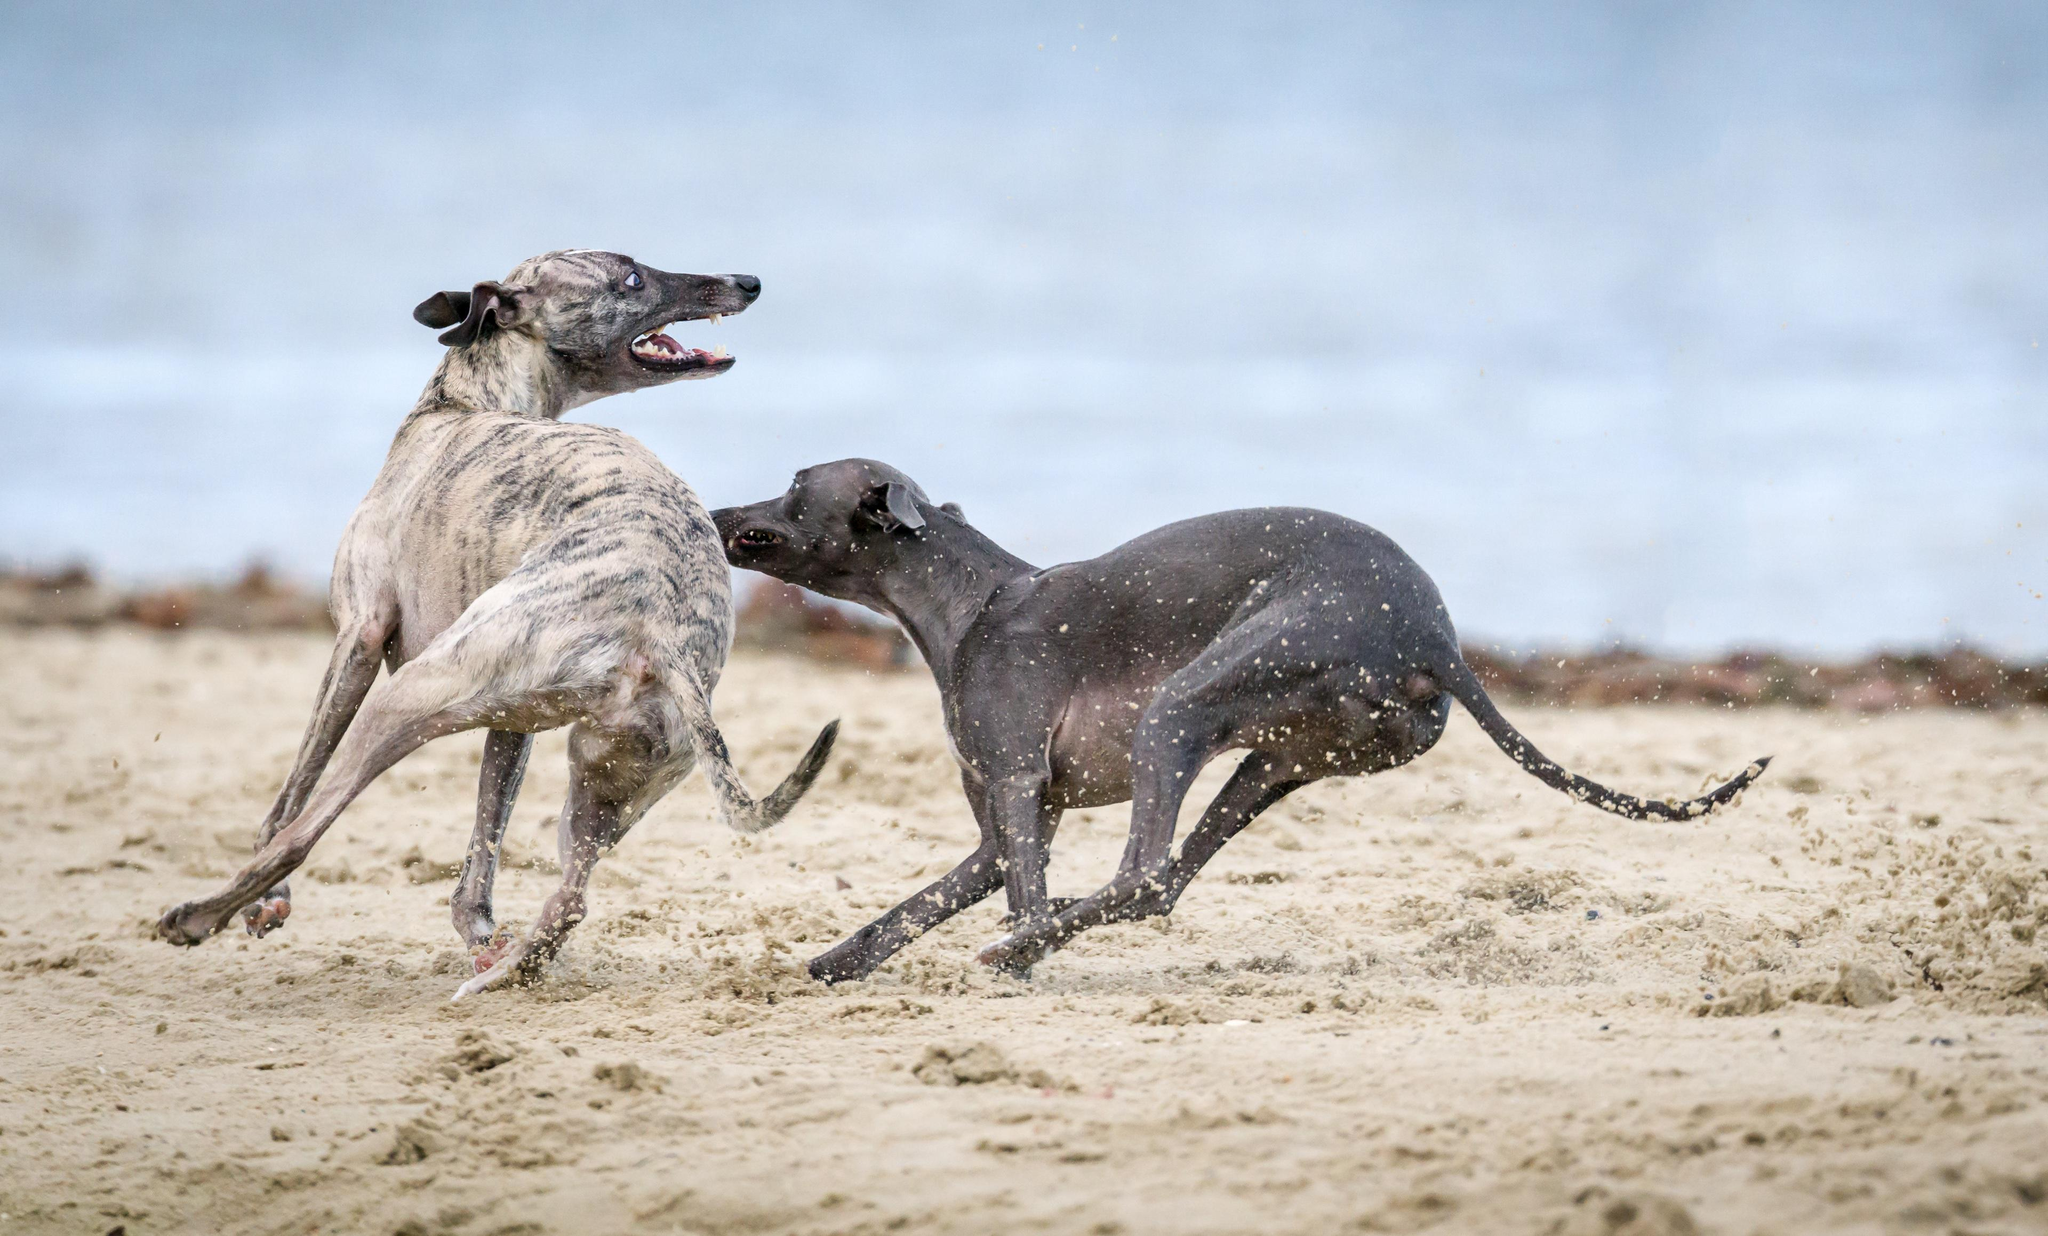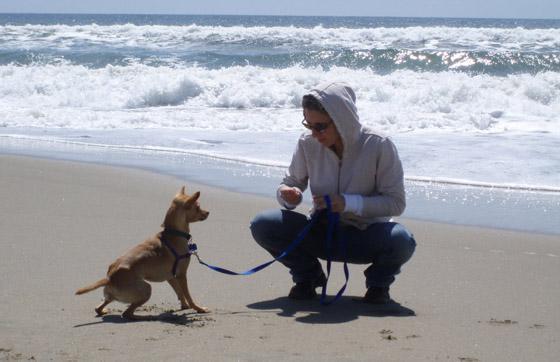The first image is the image on the left, the second image is the image on the right. Considering the images on both sides, is "Two dogs, one with an open mouth, are near one another on a sandy beach in one image." valid? Answer yes or no. Yes. The first image is the image on the left, the second image is the image on the right. For the images shown, is this caption "One of the two dogs in the left image has its mouth open, displaying its teeth and a bit of tongue." true? Answer yes or no. Yes. 